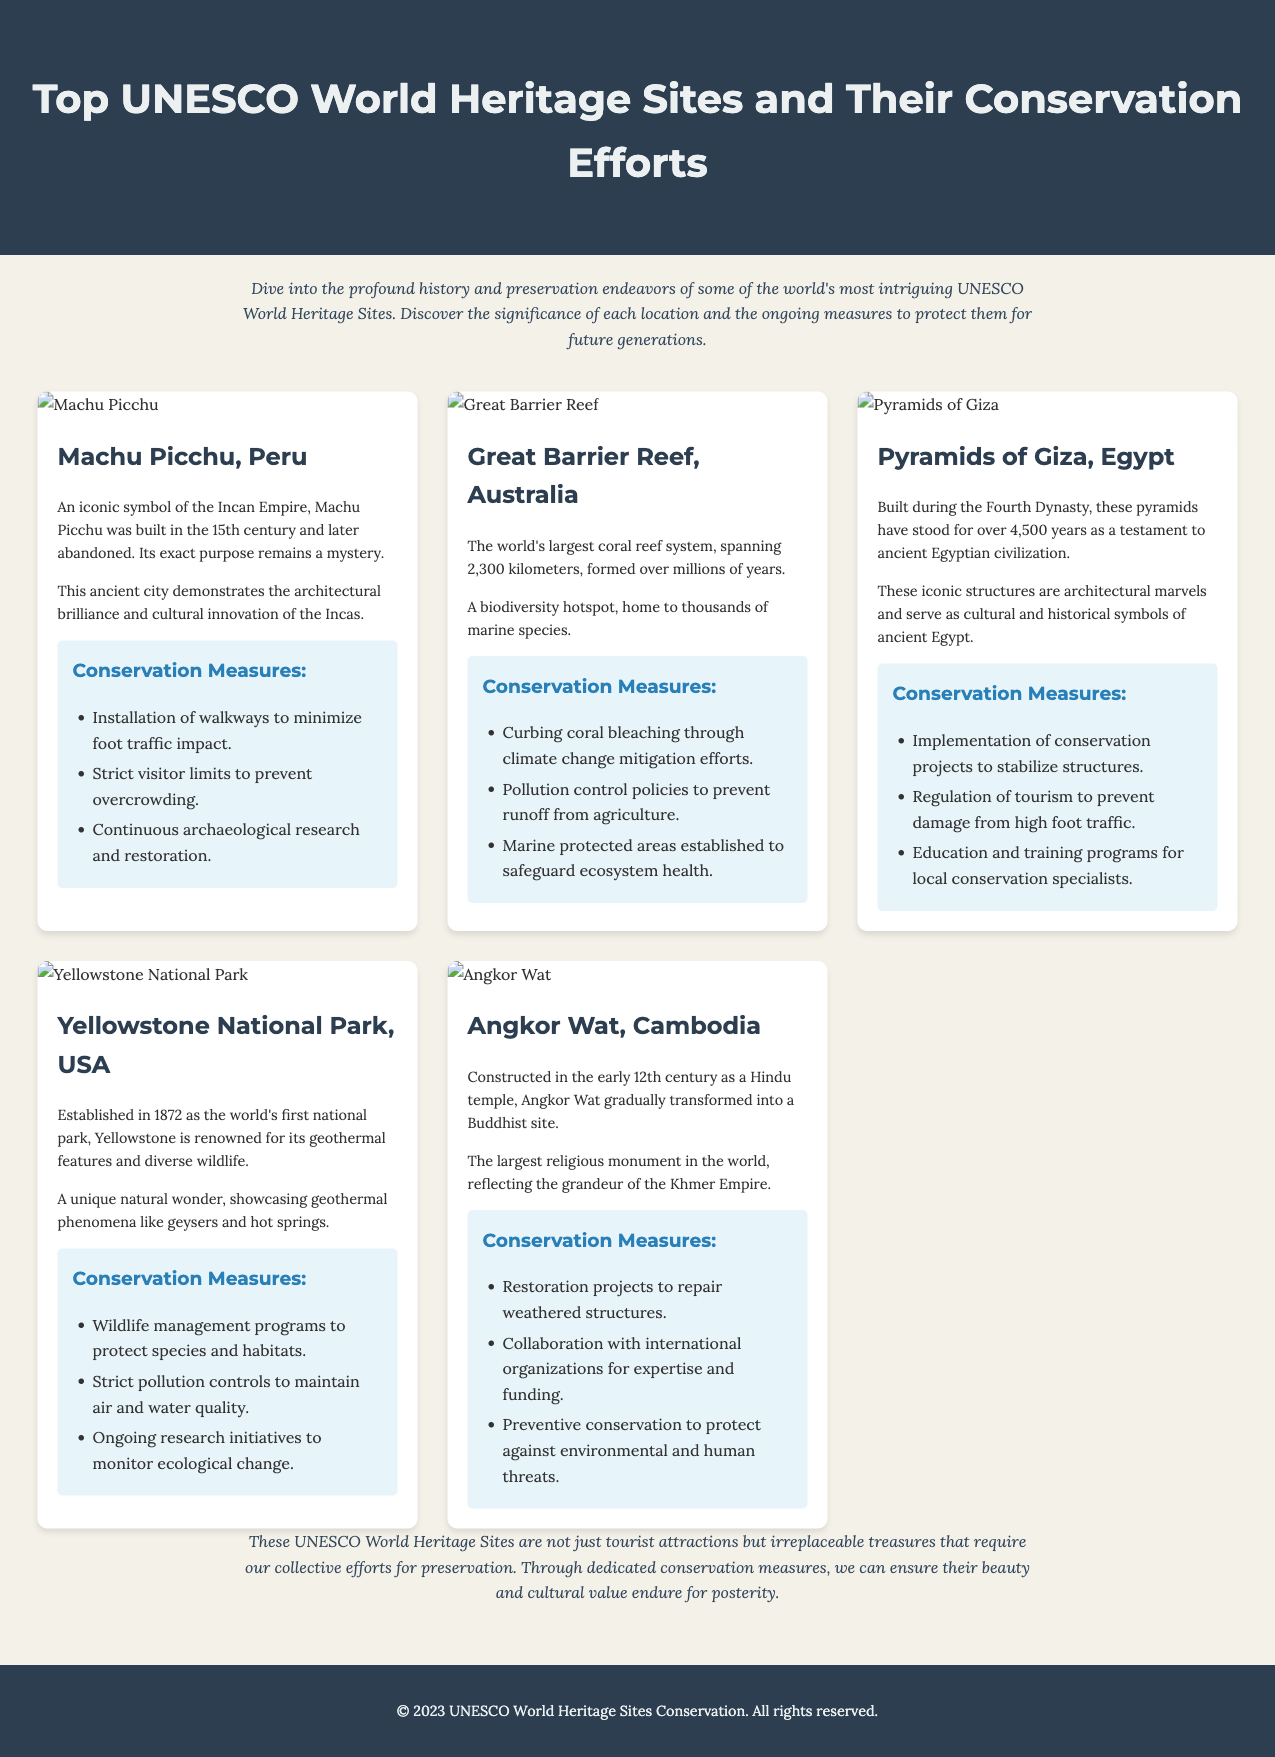What is the title of the document? The title of the document can be found in the header section, which reads "Top UNESCO World Heritage Sites and Their Conservation Efforts."
Answer: Top UNESCO World Heritage Sites and Their Conservation Efforts How many UNESCO World Heritage Sites are featured? The document showcases five distinct UNESCO World Heritage Sites, as evident in the sites grid section.
Answer: Five What is the historical significance of Machu Picchu? The document states that Machu Picchu is an iconic symbol of the Incan Empire built in the 15th century and its purpose remains a mystery.
Answer: An iconic symbol of the Incan Empire What conservation measure is implemented at Angkor Wat? The conservation measures section for Angkor Wat includes restoration projects to repair weathered structures.
Answer: Restoration projects Which site is the largest coral reef system? Based on the information present, it specifically mentions Great Barrier Reef as the largest coral reef system.
Answer: Great Barrier Reef What year was Yellowstone National Park established? The document indicates that Yellowstone National Park was established in 1872.
Answer: 1872 What is a unique feature of the Pyramids of Giza? It is highlighted in the significance that the Pyramids of Giza have stood for over 4,500 years, showcasing their architectural marvel.
Answer: Over 4,500 years What is the main focus of the conservation efforts for the Great Barrier Reef? According to the document, the main focus includes curbing coral bleaching through climate change mitigation efforts.
Answer: Curbing coral bleaching Which font is used for the titles in the document? The document specifies that titles utilize the 'Montserrat' font for visual impact.
Answer: Montserrat 